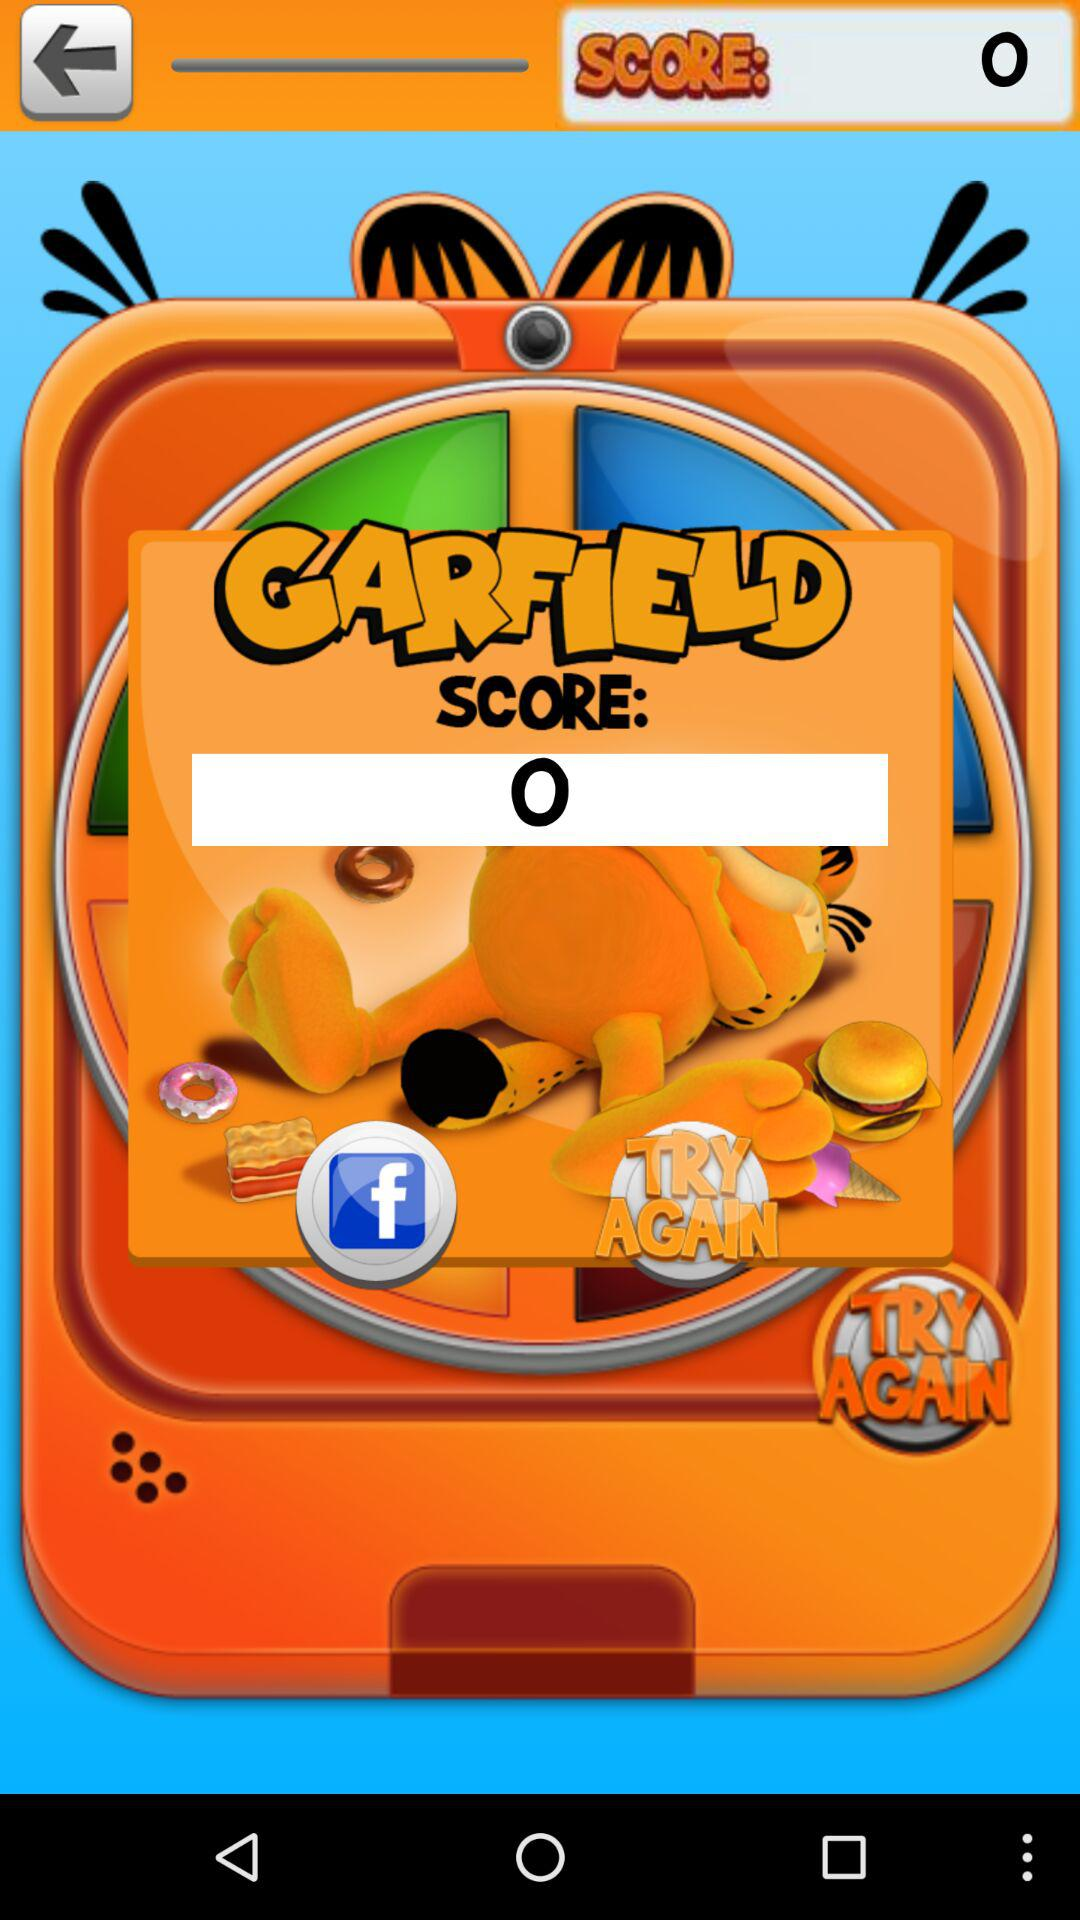What is the score? The score is 0. 